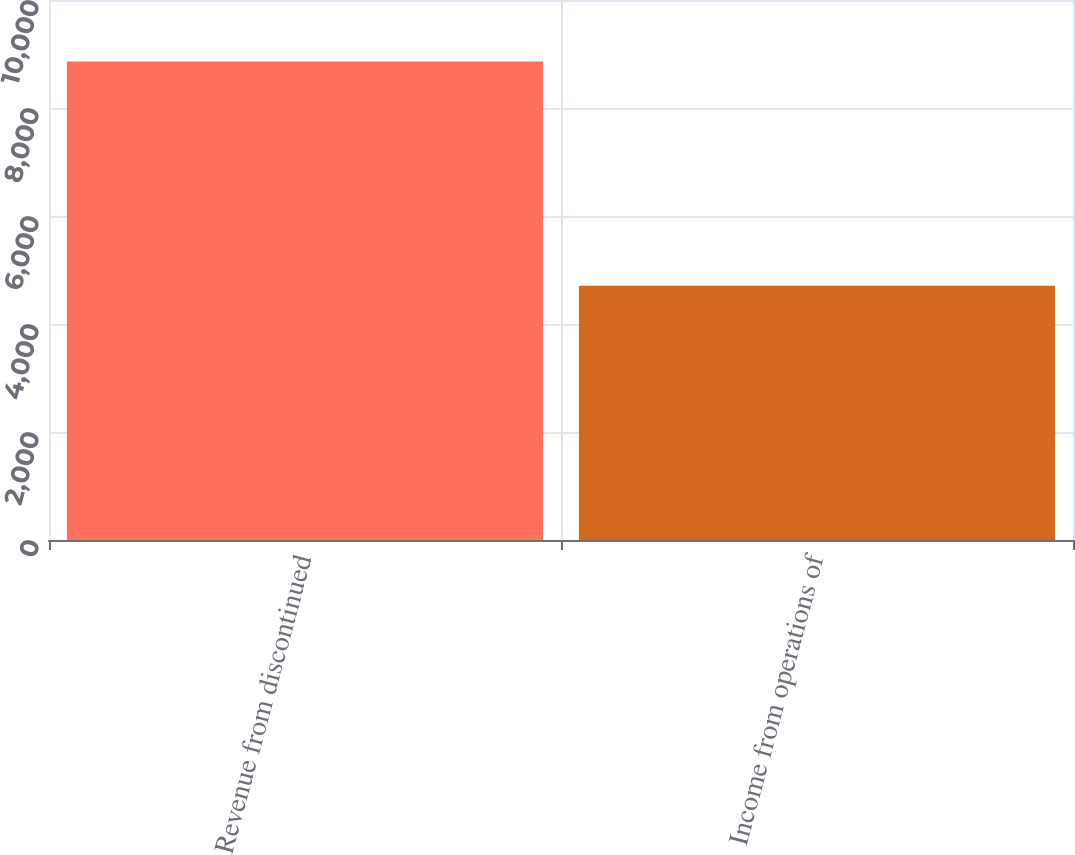Convert chart to OTSL. <chart><loc_0><loc_0><loc_500><loc_500><bar_chart><fcel>Revenue from discontinued<fcel>Income from operations of<nl><fcel>8859<fcel>4709<nl></chart> 